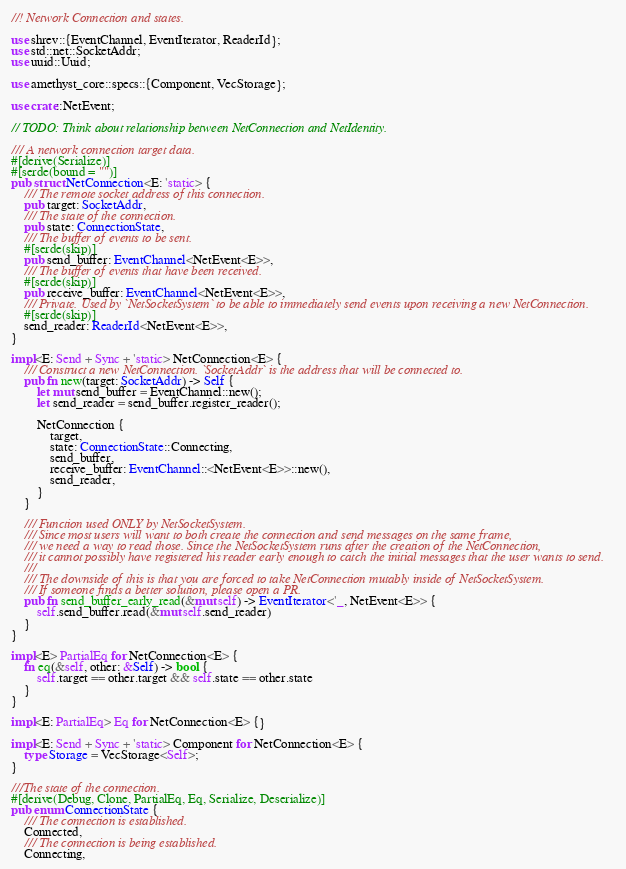<code> <loc_0><loc_0><loc_500><loc_500><_Rust_>//! Network Connection and states.

use shrev::{EventChannel, EventIterator, ReaderId};
use std::net::SocketAddr;
use uuid::Uuid;

use amethyst_core::specs::{Component, VecStorage};

use crate::NetEvent;

// TODO: Think about relationship between NetConnection and NetIdentity.

/// A network connection target data.
#[derive(Serialize)]
#[serde(bound = "")]
pub struct NetConnection<E: 'static> {
    /// The remote socket address of this connection.
    pub target: SocketAddr,
    /// The state of the connection.
    pub state: ConnectionState,
    /// The buffer of events to be sent.
    #[serde(skip)]
    pub send_buffer: EventChannel<NetEvent<E>>,
    /// The buffer of events that have been received.
    #[serde(skip)]
    pub receive_buffer: EventChannel<NetEvent<E>>,
    /// Private. Used by `NetSocketSystem` to be able to immediately send events upon receiving a new NetConnection.
    #[serde(skip)]
    send_reader: ReaderId<NetEvent<E>>,
}

impl<E: Send + Sync + 'static> NetConnection<E> {
    /// Construct a new NetConnection. `SocketAddr` is the address that will be connected to.
    pub fn new(target: SocketAddr) -> Self {
        let mut send_buffer = EventChannel::new();
        let send_reader = send_buffer.register_reader();

        NetConnection {
            target,
            state: ConnectionState::Connecting,
            send_buffer,
            receive_buffer: EventChannel::<NetEvent<E>>::new(),
            send_reader,
        }
    }

    /// Function used ONLY by NetSocketSystem.
    /// Since most users will want to both create the connection and send messages on the same frame,
    /// we need a way to read those. Since the NetSocketSystem runs after the creation of the NetConnection,
    /// it cannot possibly have registered his reader early enough to catch the initial messages that the user wants to send.
    ///
    /// The downside of this is that you are forced to take NetConnection mutably inside of NetSocketSystem.
    /// If someone finds a better solution, please open a PR.
    pub fn send_buffer_early_read(&mut self) -> EventIterator<'_, NetEvent<E>> {
        self.send_buffer.read(&mut self.send_reader)
    }
}

impl<E> PartialEq for NetConnection<E> {
    fn eq(&self, other: &Self) -> bool {
        self.target == other.target && self.state == other.state
    }
}

impl<E: PartialEq> Eq for NetConnection<E> {}

impl<E: Send + Sync + 'static> Component for NetConnection<E> {
    type Storage = VecStorage<Self>;
}

///The state of the connection.
#[derive(Debug, Clone, PartialEq, Eq, Serialize, Deserialize)]
pub enum ConnectionState {
    /// The connection is established.
    Connected,
    /// The connection is being established.
    Connecting,</code> 